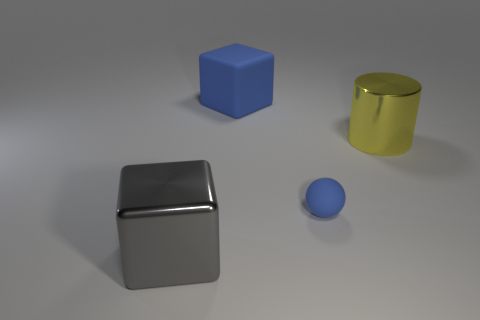How many other objects are the same color as the tiny ball?
Ensure brevity in your answer.  1. Do the matte sphere and the large rubber object have the same color?
Provide a short and direct response. Yes. There is a big metal object behind the large object that is in front of the blue sphere; what is its shape?
Offer a terse response. Cylinder. There is a blue thing left of the small blue rubber ball; how many yellow metallic cylinders are behind it?
Your answer should be very brief. 0. There is a big thing that is to the left of the tiny rubber thing and behind the tiny blue thing; what is it made of?
Keep it short and to the point. Rubber. The yellow shiny object that is the same size as the blue matte cube is what shape?
Ensure brevity in your answer.  Cylinder. What is the color of the big thing to the right of the block that is to the right of the big metal object in front of the large metal cylinder?
Offer a terse response. Yellow. What number of objects are either blue rubber things that are behind the tiny matte thing or tiny objects?
Make the answer very short. 2. There is a yellow thing that is the same size as the gray metal object; what is its material?
Keep it short and to the point. Metal. There is a large cube that is in front of the object behind the metal object behind the gray shiny block; what is it made of?
Offer a terse response. Metal. 